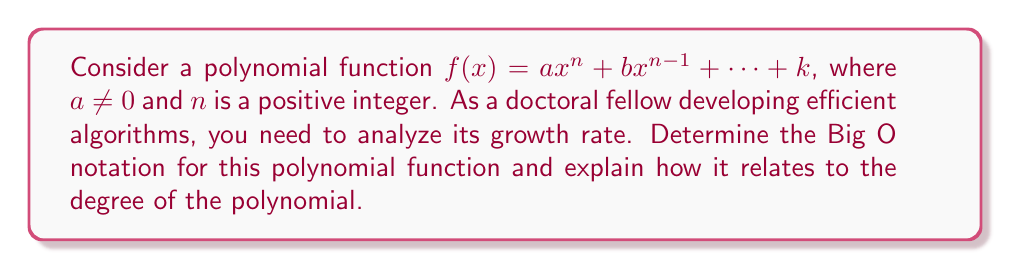Help me with this question. To analyze the growth rate of the polynomial function $f(x) = ax^n + bx^{n-1} + ... + k$, we need to consider the following steps:

1) The highest degree term in the polynomial is $ax^n$, where $n$ is the degree of the polynomial and $a \neq 0$.

2) As $x$ approaches infinity, the term with the highest degree will dominate the function's behavior. This means that for very large values of $x$, the lower degree terms become insignificant compared to $ax^n$.

3) In Big O notation, we're interested in the upper bound of the growth rate. Constants don't affect the overall growth rate for large inputs, so we can ignore the coefficient $a$.

4) Therefore, the growth rate of $f(x)$ is bounded above by $x^n$ for large values of $x$.

5) In Big O notation, this is expressed as $O(x^n)$.

6) This result shows that the growth rate of a polynomial function is directly related to its degree. A polynomial of degree $n$ will always have a growth rate of $O(x^n)$.

7) For algorithm analysis, this means that as the input size (represented by $x$) increases, the time or space complexity of an algorithm with polynomial time complexity will grow proportionally to $x^n$, where $n$ is the highest degree in the polynomial representing the algorithm's complexity.
Answer: $O(x^n)$ 